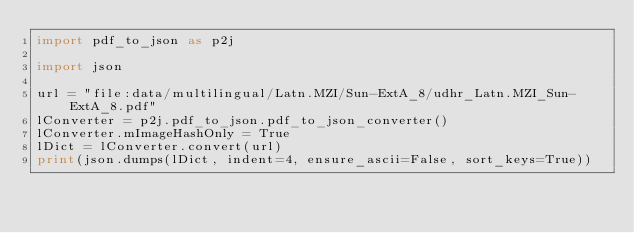Convert code to text. <code><loc_0><loc_0><loc_500><loc_500><_Python_>import pdf_to_json as p2j

import json

url = "file:data/multilingual/Latn.MZI/Sun-ExtA_8/udhr_Latn.MZI_Sun-ExtA_8.pdf"
lConverter = p2j.pdf_to_json.pdf_to_json_converter()
lConverter.mImageHashOnly = True
lDict = lConverter.convert(url)
print(json.dumps(lDict, indent=4, ensure_ascii=False, sort_keys=True))
</code> 